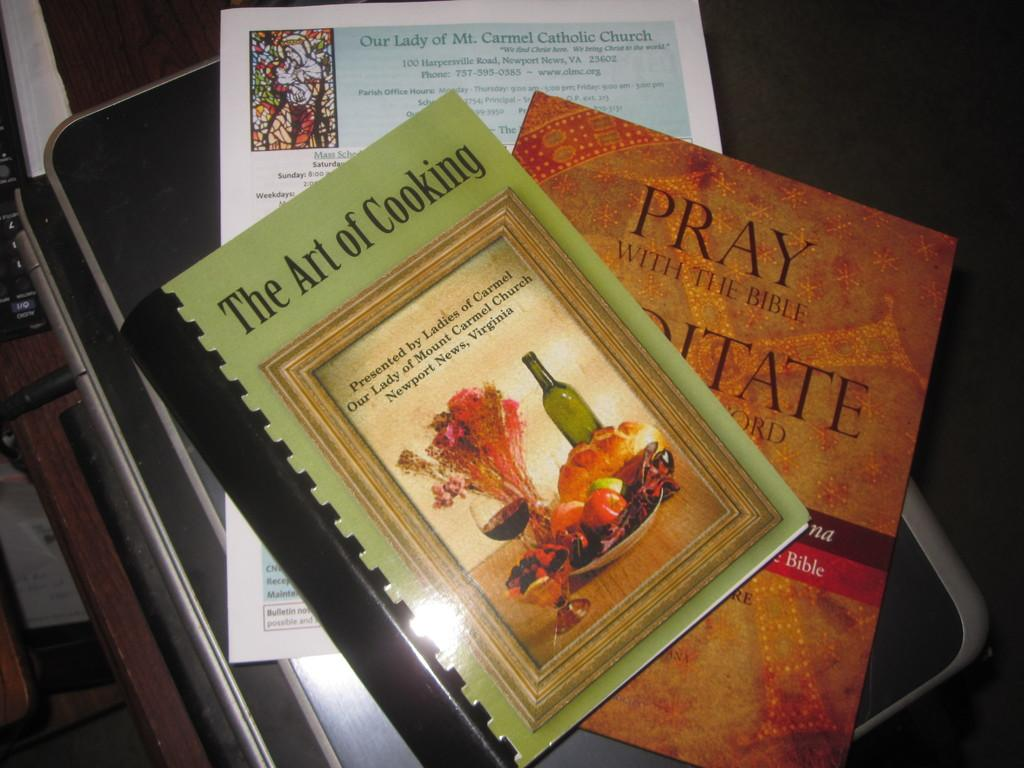Provide a one-sentence caption for the provided image. Books on the Art of Cooking and Pray with the Bible. 